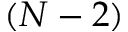<formula> <loc_0><loc_0><loc_500><loc_500>( N - 2 )</formula> 